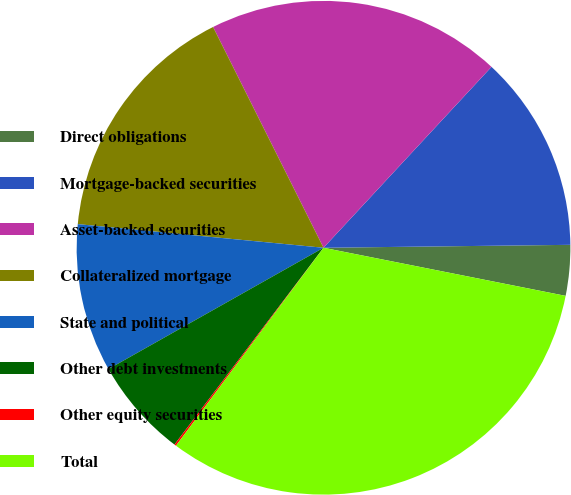Convert chart. <chart><loc_0><loc_0><loc_500><loc_500><pie_chart><fcel>Direct obligations<fcel>Mortgage-backed securities<fcel>Asset-backed securities<fcel>Collateralized mortgage<fcel>State and political<fcel>Other debt investments<fcel>Other equity securities<fcel>Total<nl><fcel>3.31%<fcel>12.9%<fcel>19.29%<fcel>16.09%<fcel>9.7%<fcel>6.51%<fcel>0.12%<fcel>32.07%<nl></chart> 